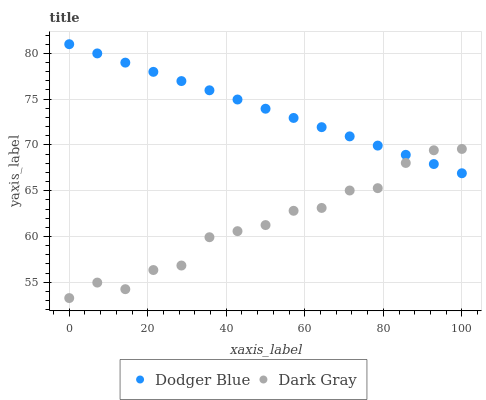Does Dark Gray have the minimum area under the curve?
Answer yes or no. Yes. Does Dodger Blue have the maximum area under the curve?
Answer yes or no. Yes. Does Dodger Blue have the minimum area under the curve?
Answer yes or no. No. Is Dodger Blue the smoothest?
Answer yes or no. Yes. Is Dark Gray the roughest?
Answer yes or no. Yes. Is Dodger Blue the roughest?
Answer yes or no. No. Does Dark Gray have the lowest value?
Answer yes or no. Yes. Does Dodger Blue have the lowest value?
Answer yes or no. No. Does Dodger Blue have the highest value?
Answer yes or no. Yes. Does Dark Gray intersect Dodger Blue?
Answer yes or no. Yes. Is Dark Gray less than Dodger Blue?
Answer yes or no. No. Is Dark Gray greater than Dodger Blue?
Answer yes or no. No. 